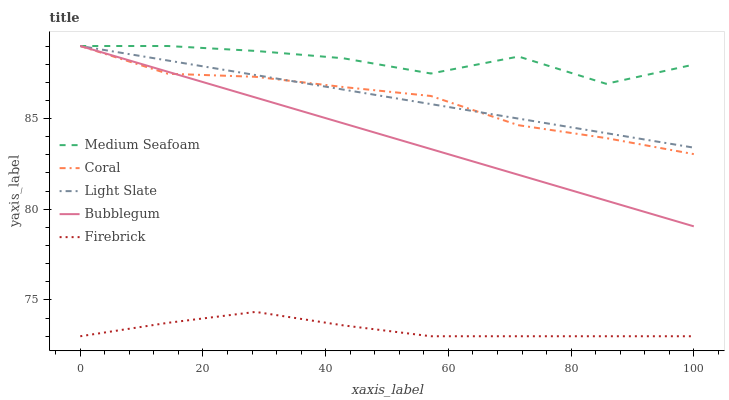Does Firebrick have the minimum area under the curve?
Answer yes or no. Yes. Does Medium Seafoam have the maximum area under the curve?
Answer yes or no. Yes. Does Coral have the minimum area under the curve?
Answer yes or no. No. Does Coral have the maximum area under the curve?
Answer yes or no. No. Is Light Slate the smoothest?
Answer yes or no. Yes. Is Medium Seafoam the roughest?
Answer yes or no. Yes. Is Firebrick the smoothest?
Answer yes or no. No. Is Firebrick the roughest?
Answer yes or no. No. Does Firebrick have the lowest value?
Answer yes or no. Yes. Does Coral have the lowest value?
Answer yes or no. No. Does Bubblegum have the highest value?
Answer yes or no. Yes. Does Firebrick have the highest value?
Answer yes or no. No. Is Firebrick less than Bubblegum?
Answer yes or no. Yes. Is Coral greater than Firebrick?
Answer yes or no. Yes. Does Coral intersect Medium Seafoam?
Answer yes or no. Yes. Is Coral less than Medium Seafoam?
Answer yes or no. No. Is Coral greater than Medium Seafoam?
Answer yes or no. No. Does Firebrick intersect Bubblegum?
Answer yes or no. No. 